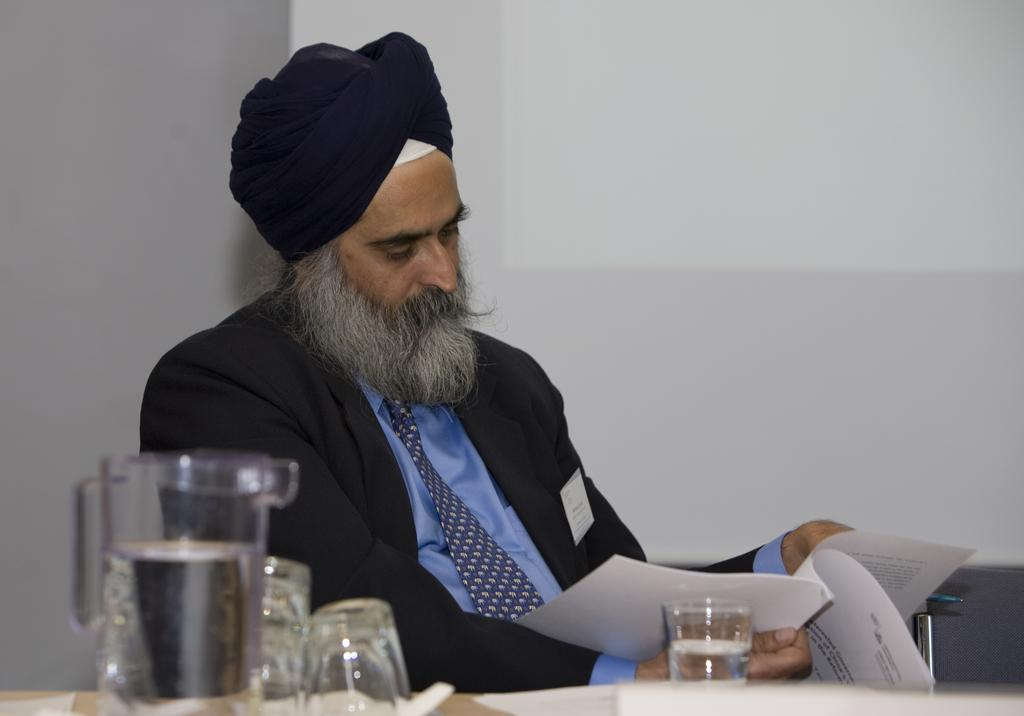What is the main subject of the image? There is a person in the image. What is the person wearing? The person is wearing clothes. What is the person holding in the image? The person is holding a book. What objects can be seen at the bottom of the image? There are glasses and a jug at the bottom of the image. What position does the bee hold in the image? There is no bee present in the image. What force is being applied by the person in the image? The provided facts do not mention any force being applied by the person in the image. 